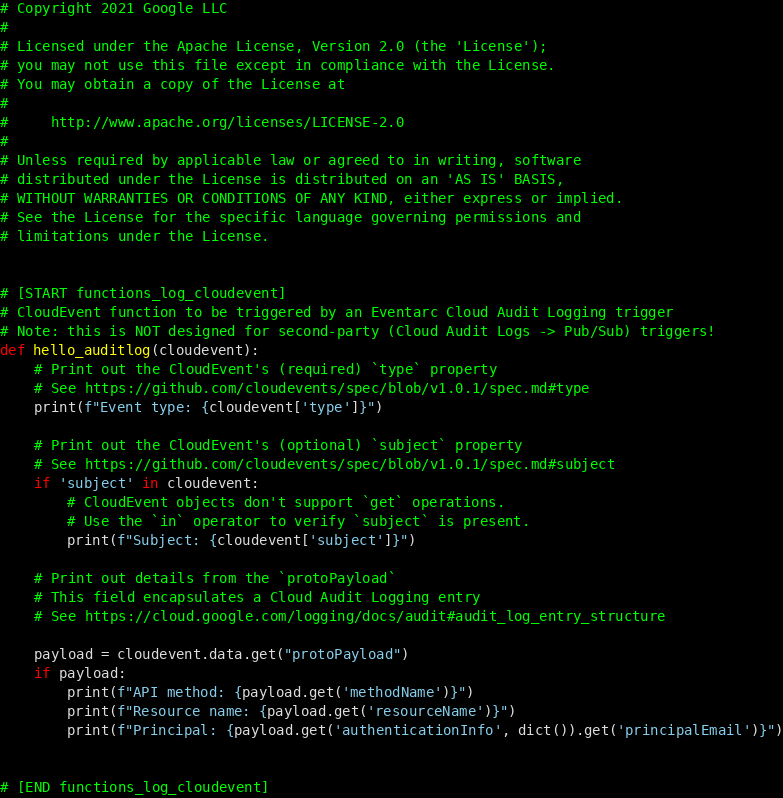<code> <loc_0><loc_0><loc_500><loc_500><_Python_># Copyright 2021 Google LLC
#
# Licensed under the Apache License, Version 2.0 (the 'License');
# you may not use this file except in compliance with the License.
# You may obtain a copy of the License at
#
#     http://www.apache.org/licenses/LICENSE-2.0
#
# Unless required by applicable law or agreed to in writing, software
# distributed under the License is distributed on an 'AS IS' BASIS,
# WITHOUT WARRANTIES OR CONDITIONS OF ANY KIND, either express or implied.
# See the License for the specific language governing permissions and
# limitations under the License.


# [START functions_log_cloudevent]
# CloudEvent function to be triggered by an Eventarc Cloud Audit Logging trigger
# Note: this is NOT designed for second-party (Cloud Audit Logs -> Pub/Sub) triggers!
def hello_auditlog(cloudevent):
    # Print out the CloudEvent's (required) `type` property
    # See https://github.com/cloudevents/spec/blob/v1.0.1/spec.md#type
    print(f"Event type: {cloudevent['type']}")

    # Print out the CloudEvent's (optional) `subject` property
    # See https://github.com/cloudevents/spec/blob/v1.0.1/spec.md#subject
    if 'subject' in cloudevent:
        # CloudEvent objects don't support `get` operations.
        # Use the `in` operator to verify `subject` is present.
        print(f"Subject: {cloudevent['subject']}")

    # Print out details from the `protoPayload`
    # This field encapsulates a Cloud Audit Logging entry
    # See https://cloud.google.com/logging/docs/audit#audit_log_entry_structure

    payload = cloudevent.data.get("protoPayload")
    if payload:
        print(f"API method: {payload.get('methodName')}")
        print(f"Resource name: {payload.get('resourceName')}")
        print(f"Principal: {payload.get('authenticationInfo', dict()).get('principalEmail')}")


# [END functions_log_cloudevent]
</code> 